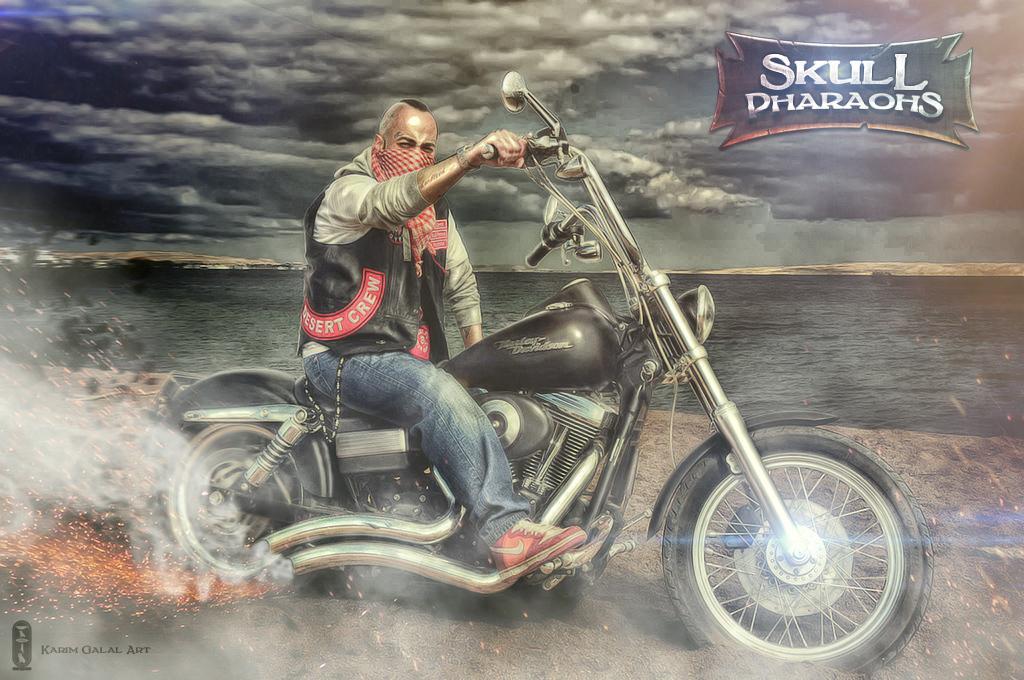Can you describe this image briefly? This is an animated image. In the middle of this image, there is a person holding a handle and sitting on a bike. On the left side, there is fire and there is smoke from tubes. On the bottom left, there is a watermark. On the top right, there is a watermark. In the background, there is water, there are mountains and there are clouds in the sky. 